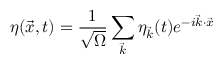<formula> <loc_0><loc_0><loc_500><loc_500>\eta ( \vec { x } , t ) = \frac { 1 } { \sqrt { \Omega } } \sum _ { \vec { k } } \eta _ { \vec { k } } ( t ) e ^ { - i \vec { k } \cdot \vec { x } }</formula> 